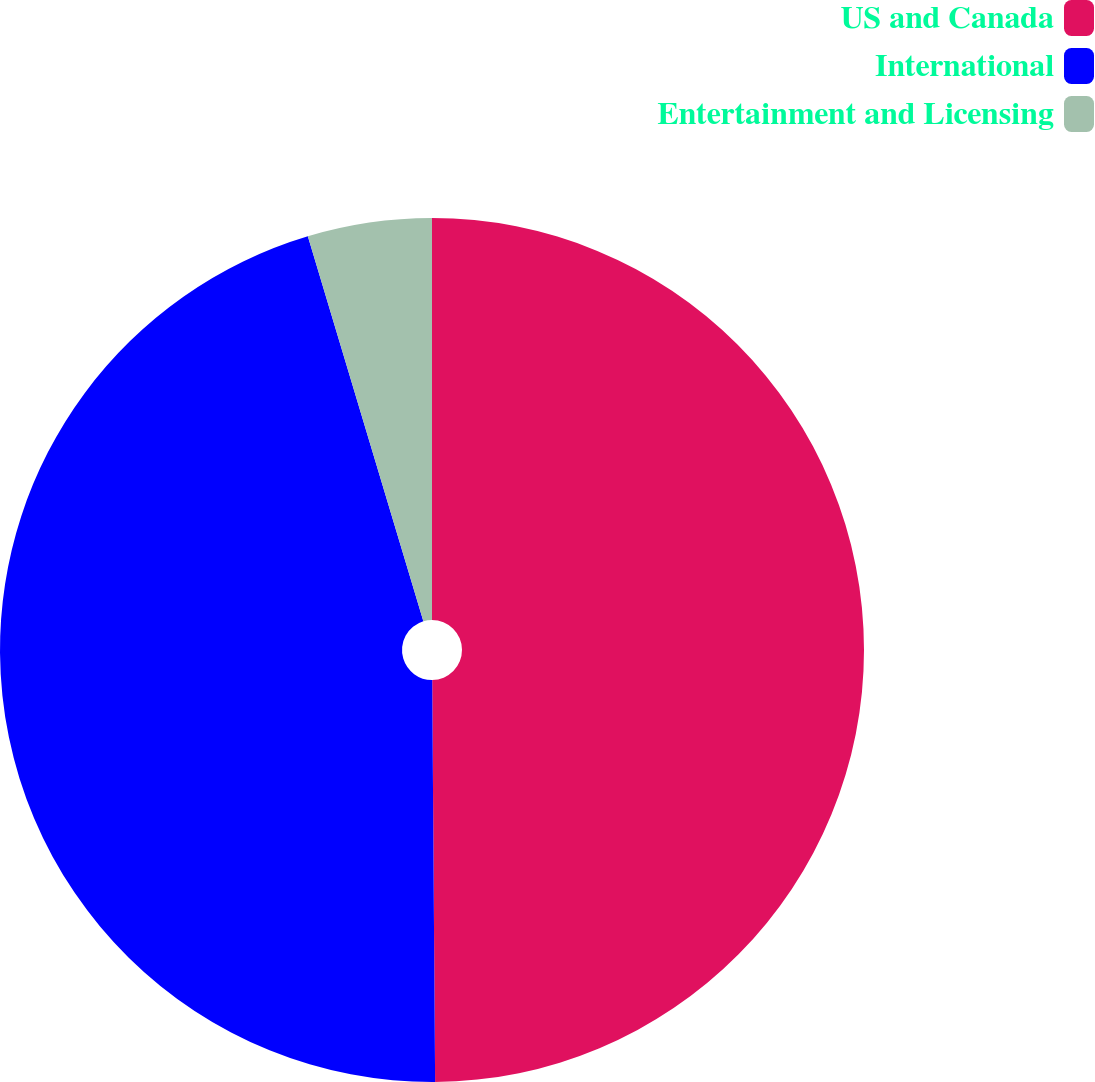Convert chart to OTSL. <chart><loc_0><loc_0><loc_500><loc_500><pie_chart><fcel>US and Canada<fcel>International<fcel>Entertainment and Licensing<nl><fcel>49.89%<fcel>45.48%<fcel>4.64%<nl></chart> 